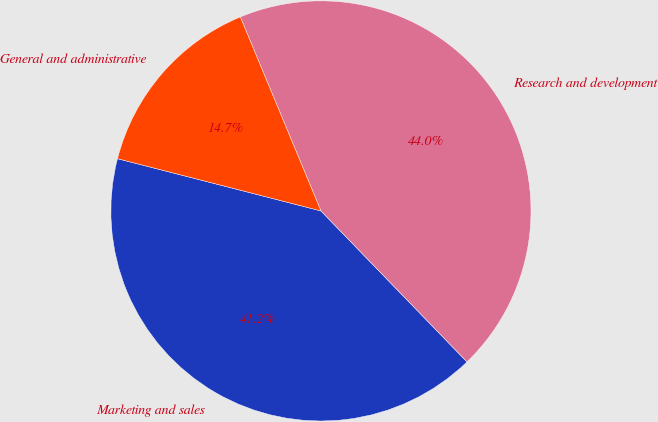Convert chart to OTSL. <chart><loc_0><loc_0><loc_500><loc_500><pie_chart><fcel>Marketing and sales<fcel>Research and development<fcel>General and administrative<nl><fcel>41.24%<fcel>44.04%<fcel>14.73%<nl></chart> 